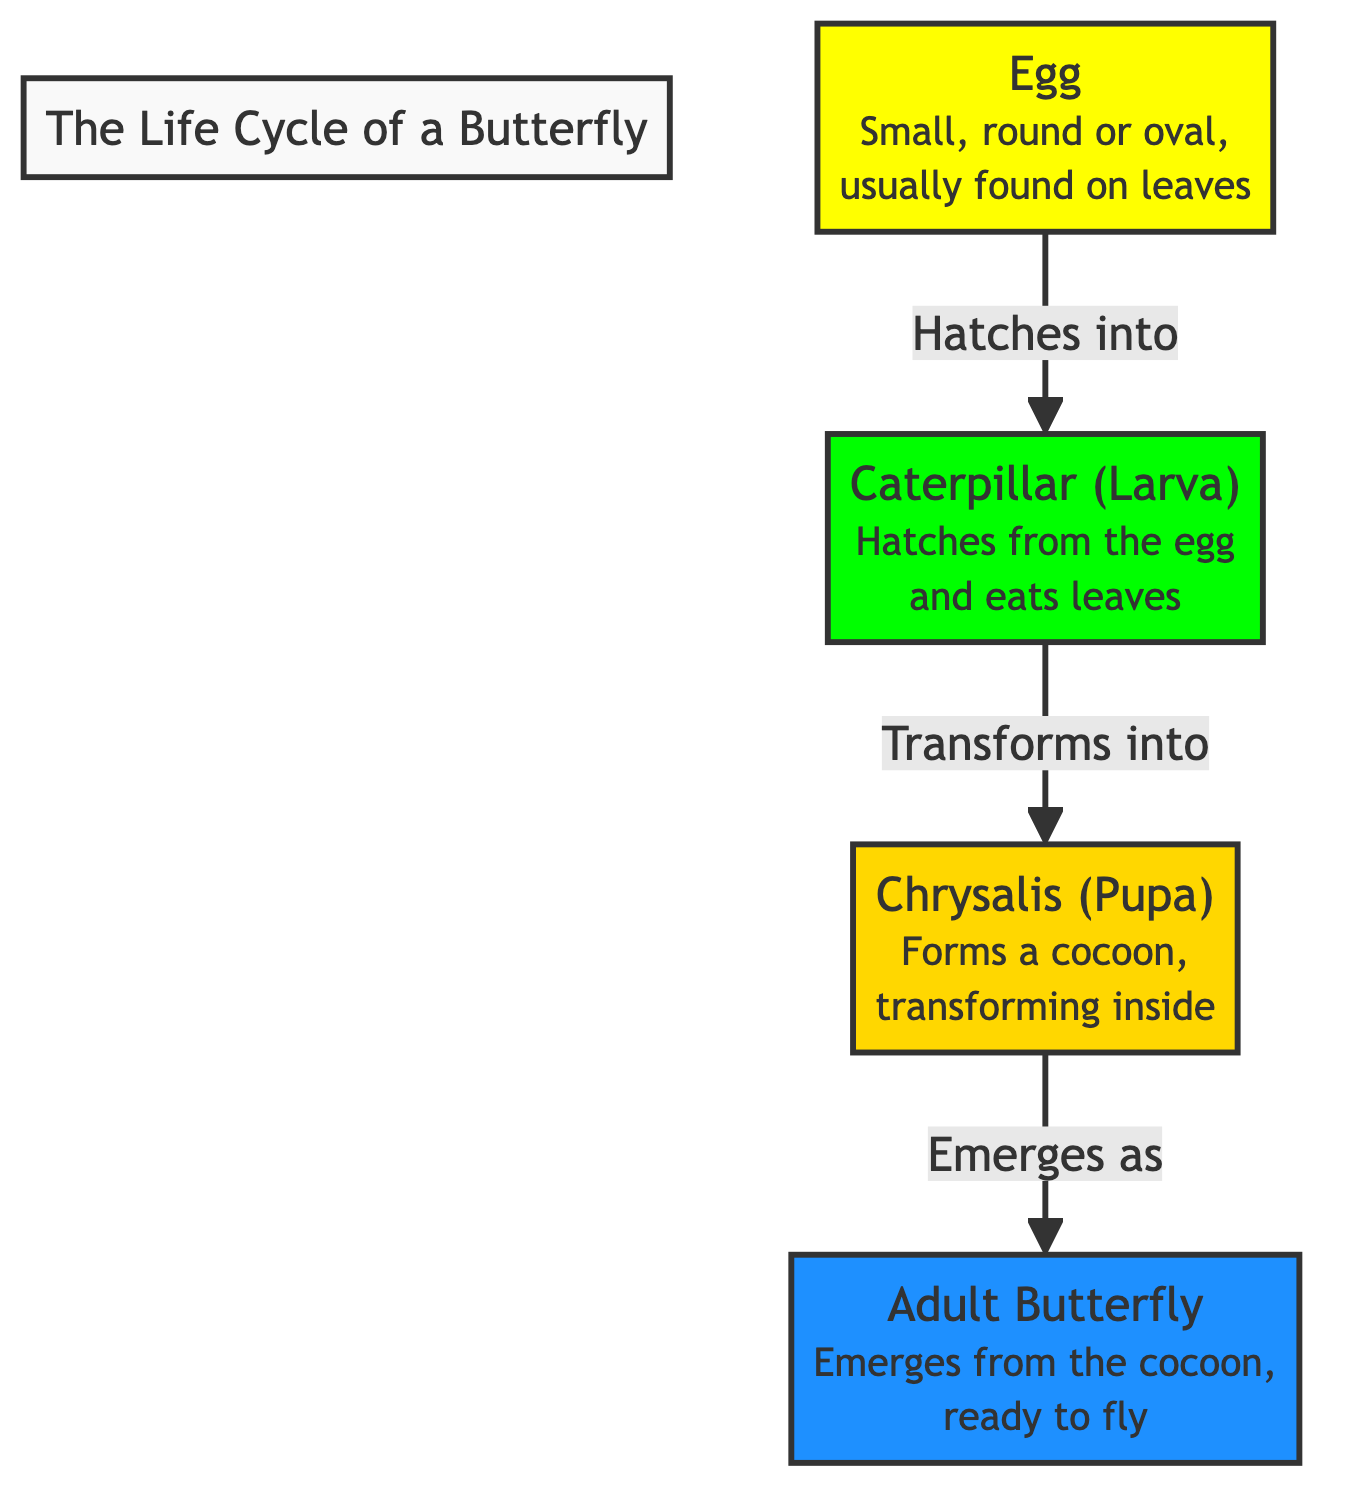What are the stages of the butterfly life cycle shown in the diagram? The diagram presents four distinct stages: Egg, Caterpillar (Larva), Chrysalis (Pupa), and Adult Butterfly. These stages are connected sequentially to depict the life cycle.
Answer: Egg, Caterpillar, Chrysalis, Adult Butterfly How many total stages are depicted in the butterfly life cycle? Upon examining the diagram, there are four major stages represented: Egg, Caterpillar, Chrysalis, and Butterfly.
Answer: Four What color represents the butterfly stage? Looking at the diagram, the Adult Butterfly stage is illustrated using the color blue, specifically a bright shade indicated by the hex code given for the butterfly class, which is #1e90ff.
Answer: Blue What does the caterpillar do after hatching from the egg? The diagram indicates that the caterpillar eats leaves after it hatches from the egg, which is elaborated in the description for the caterpillar stage.
Answer: Eats leaves What is the shape of the egg stage? In the visual representation, the egg stage is described as small, round, or oval, as mentioned in the diagram.
Answer: Round or oval What process occurs in the chrysalis stage? The diagram highlights that during the chrysalis stage, the caterpillar transforms inside a cocoon, which is a crucial part of its life cycle. This transformation process is indicated in the description of the chrysalis stage.
Answer: Transformation Which stage directly follows the chrysalis stage? By following the arrows in the diagram, the stage that comes after the chrysalis is the Adult Butterfly stage, indicating the order of progression in the life cycle.
Answer: Adult Butterfly What is the function of the chrysalis? The diagram informs us that the chrysalis serves as a protective cocoon where the caterpillar undergoes transformation, transitioning into an adult butterfly. This is based on the short description provided in the diagram for the chrysalis stage.
Answer: Protective cocoon What does the title of the diagram indicate? The title states "The Life Cycle of a Butterfly," which clearly describes the main focus of the diagram and summarizes the content it presents regarding the butterfly's development.
Answer: The Life Cycle of a Butterfly 